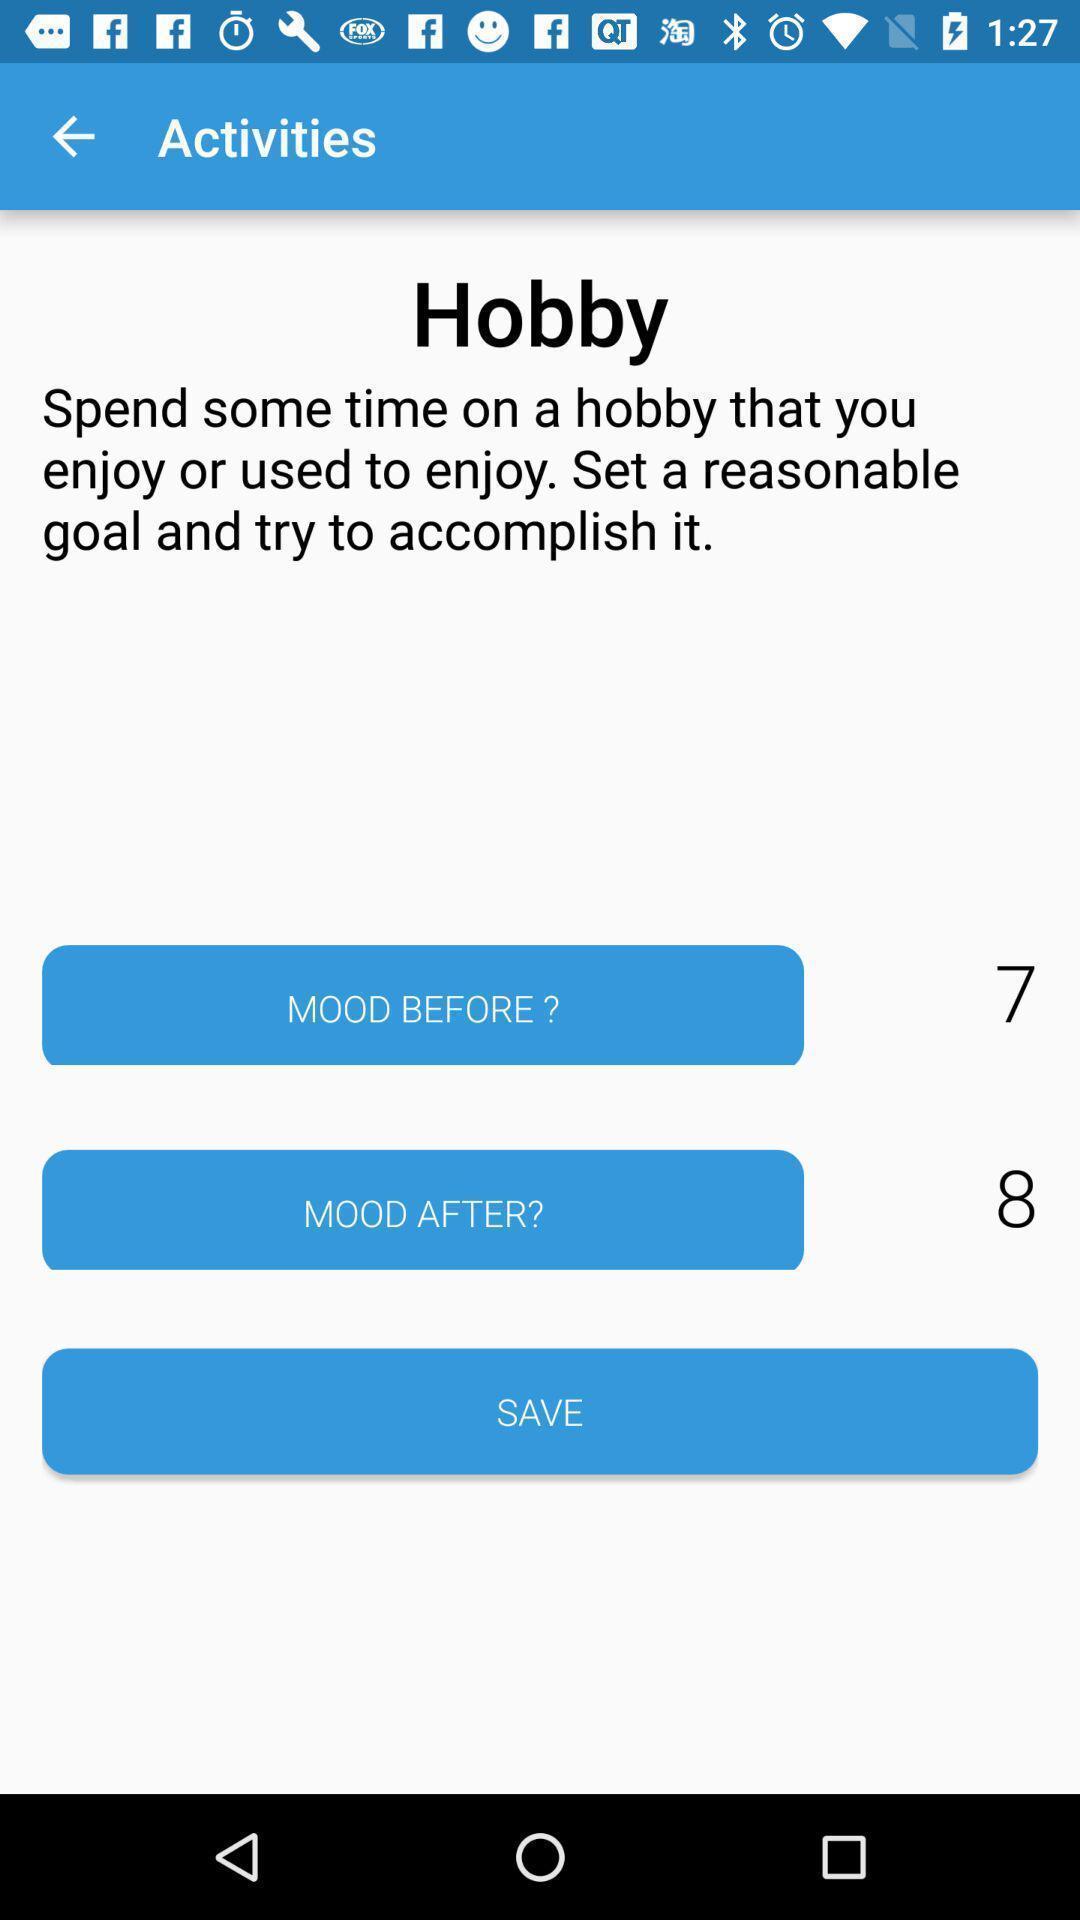Tell me what you see in this picture. Page showing activities on the mood app. 